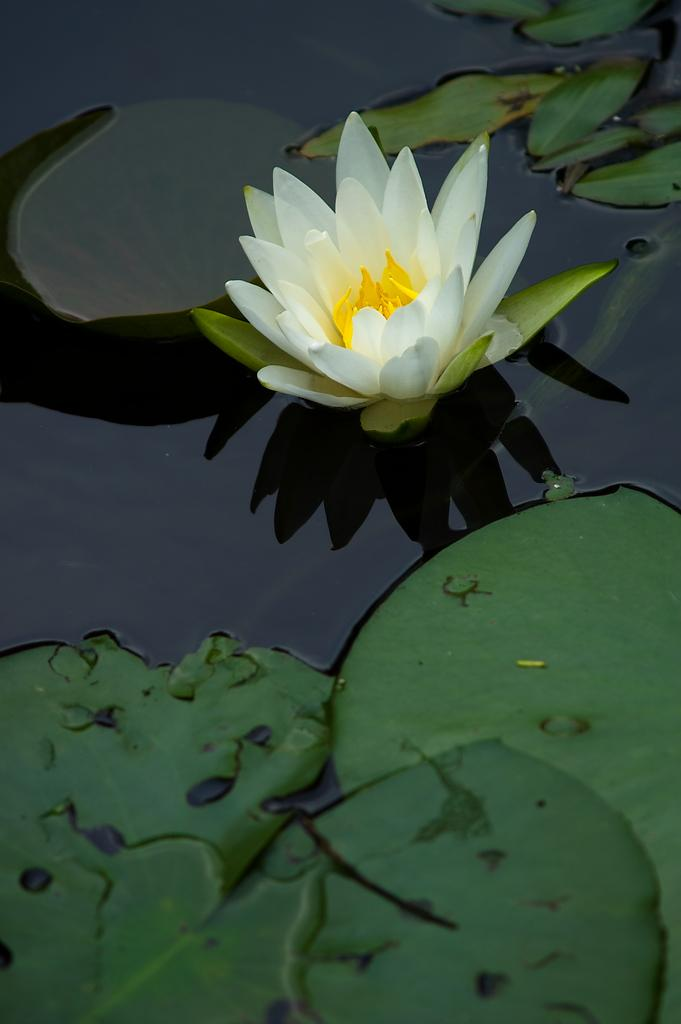What is the main subject of the image? There is a flower in the image. Can you describe the color of the flower? The flower is in white and yellow color. What else can be seen in the image besides the flower? There are leaves in the image. What is the color of the leaves? The leaves are in green color. Can you see a frog biting the flower in the image? There is no frog or any indication of biting in the image; it only features a flower and leaves. 